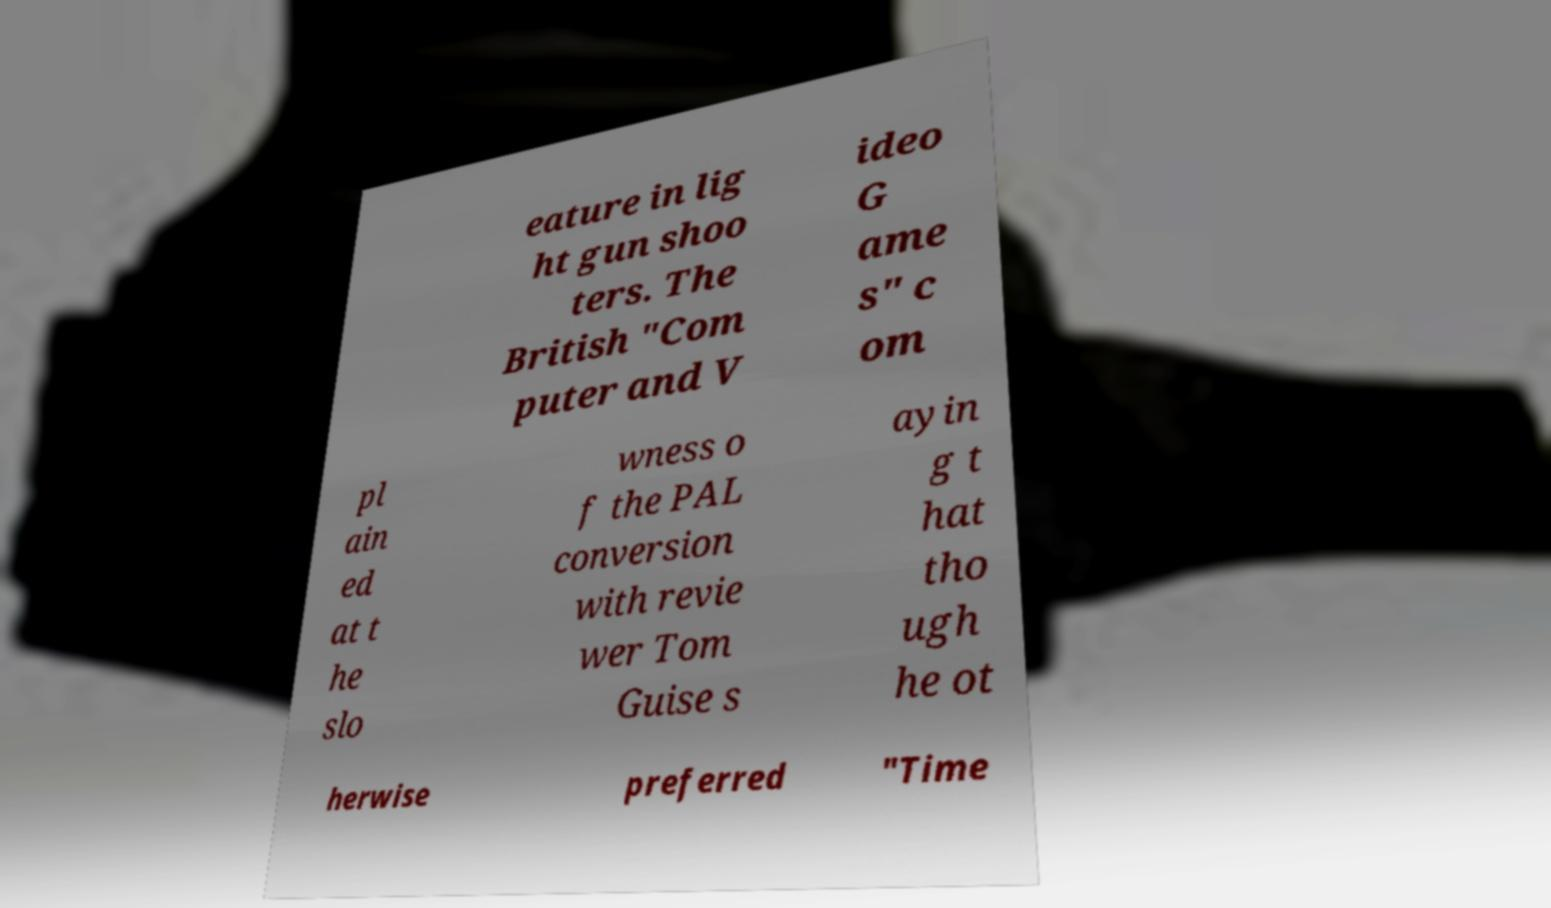Can you accurately transcribe the text from the provided image for me? eature in lig ht gun shoo ters. The British "Com puter and V ideo G ame s" c om pl ain ed at t he slo wness o f the PAL conversion with revie wer Tom Guise s ayin g t hat tho ugh he ot herwise preferred "Time 